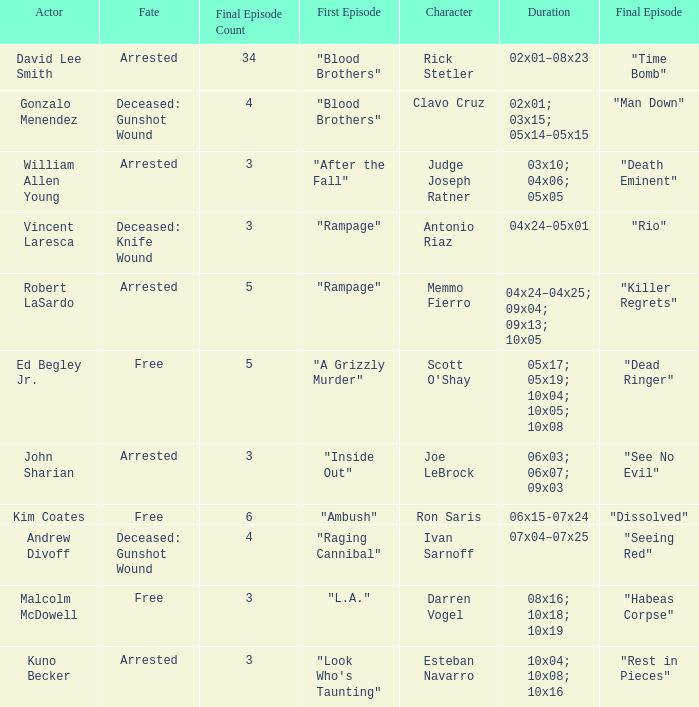What is the total count of final episodes, with the first episode titled "l.a."? 1.0. 